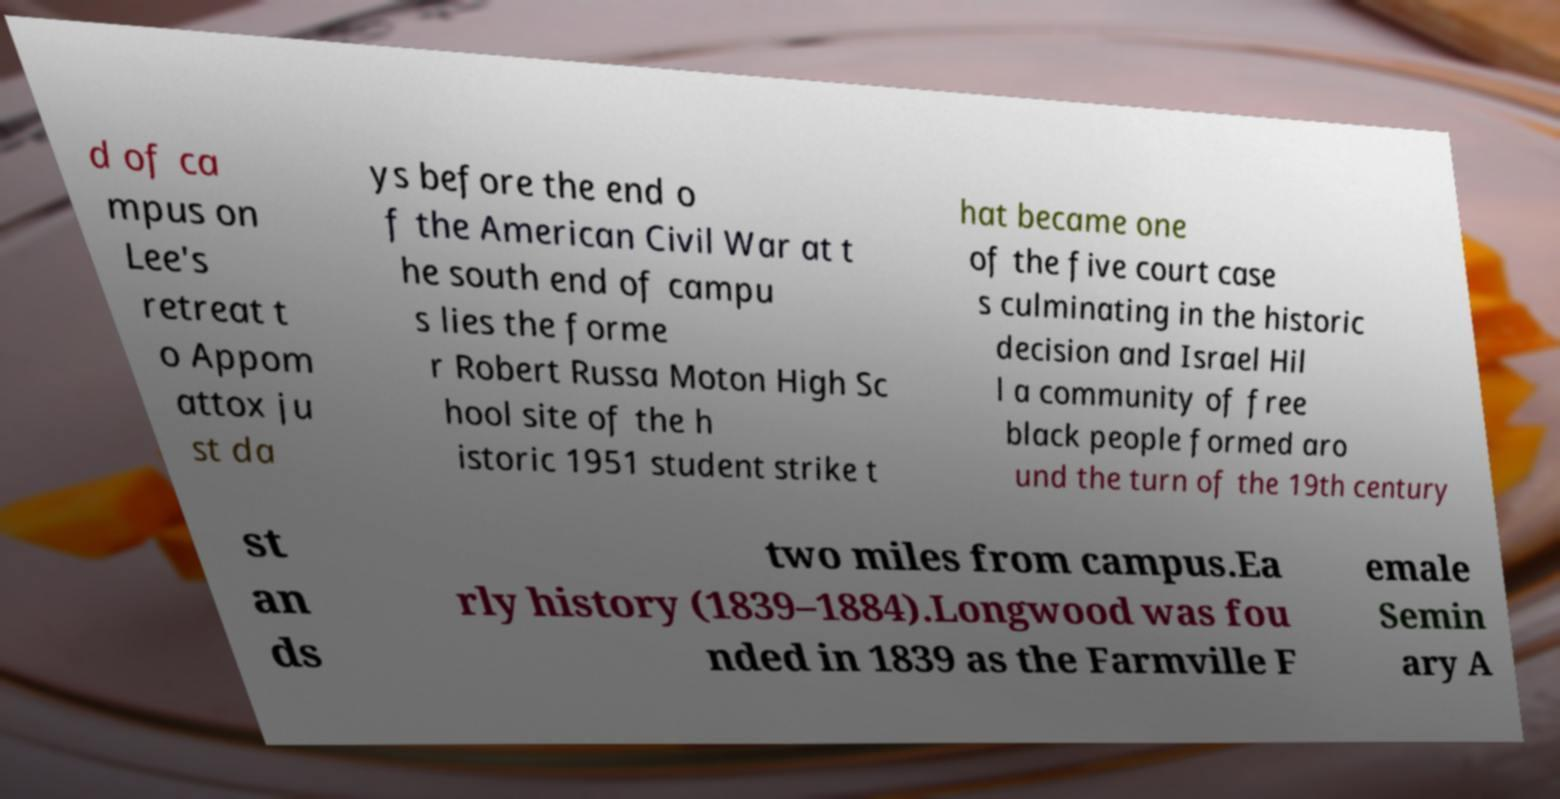Please identify and transcribe the text found in this image. d of ca mpus on Lee's retreat t o Appom attox ju st da ys before the end o f the American Civil War at t he south end of campu s lies the forme r Robert Russa Moton High Sc hool site of the h istoric 1951 student strike t hat became one of the five court case s culminating in the historic decision and Israel Hil l a community of free black people formed aro und the turn of the 19th century st an ds two miles from campus.Ea rly history (1839–1884).Longwood was fou nded in 1839 as the Farmville F emale Semin ary A 